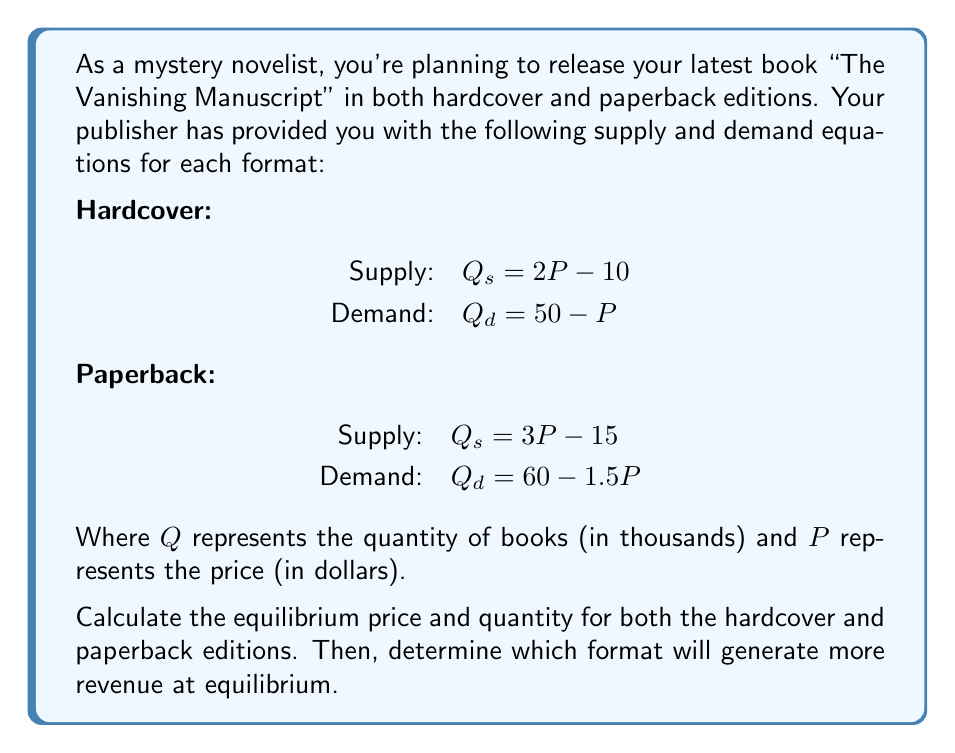What is the answer to this math problem? Let's solve this problem step by step:

1. For the hardcover edition:
   At equilibrium, supply equals demand: $Q_s = Q_d$
   $2P - 10 = 50 - P$
   $3P = 60$
   $P = 20$

   Substituting this price back into either equation:
   $Q = 2(20) - 10 = 30$ or $Q = 50 - 20 = 30$

   Equilibrium for hardcover: Price = $20, Quantity = 30 thousand

2. For the paperback edition:
   At equilibrium: $3P - 15 = 60 - 1.5P$
   $4.5P = 75$
   $P = 16.67$ (rounded to 2 decimal places)

   Substituting this price:
   $Q = 3(16.67) - 15 = 35$ thousand (rounded)

   Equilibrium for paperback: Price = $16.67, Quantity = 35 thousand

3. To determine which format generates more revenue:
   Hardcover revenue: $R_h = P \times Q = 20 \times 30,000 = $600,000$
   Paperback revenue: $R_p = P \times Q = 16.67 \times 35,000 = $583,450$

Therefore, the hardcover edition will generate more revenue at equilibrium.
Answer: Hardcover equilibrium: Price = $20, Quantity = 30,000
Paperback equilibrium: Price = $16.67, Quantity = 35,000
The hardcover edition will generate more revenue ($600,000 vs $583,450). 